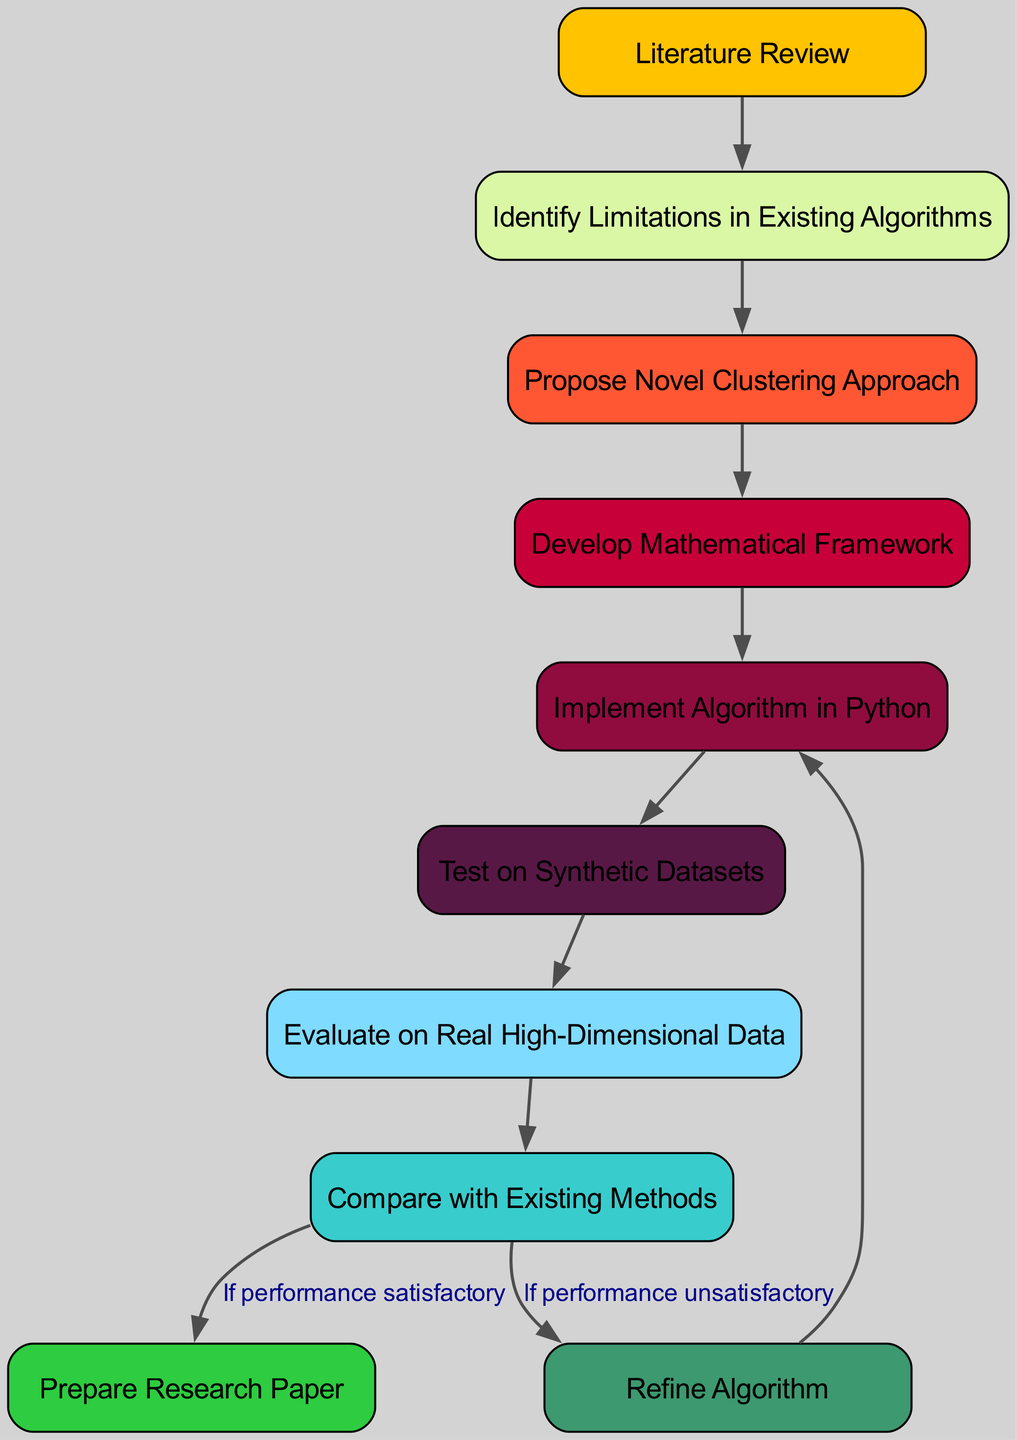What is the first step in the process? The first node in the diagram is "Literature Review," indicating that this is the initial step in the development of the clustering algorithm.
Answer: Literature Review How many nodes are present in the diagram? The diagram lists a total of ten nodes representing different steps in developing the clustering algorithm.
Answer: 10 What is the immediate next step after "Propose Novel Clustering Approach"? The flowchart indicates that after proposing a novel approach, the next step is to "Develop Mathematical Framework," which connects these two nodes.
Answer: Develop Mathematical Framework What decision follows the "Evaluate on Real High-Dimensional Data" step? After evaluating on real high-dimensional data, the flowchart leads to two paths: if performance is satisfactory, it goes to "Prepare Research Paper"; if not, it goes to "Compare with Existing Methods." This illustrates a decision point based on performance.
Answer: Compare with Existing Methods or Prepare Research Paper What is the process to refine the algorithm? To refine the algorithm, the diagram shows moving from "Compare with Existing Methods" and, if performance is unsatisfactory, returning to "Implement Algorithm in Python," indicating an iterative improvement process.
Answer: Implement Algorithm in Python What happens after "Test on Synthetic Datasets"? Following the testing on synthetic datasets, the next step is "Evaluate on Real High-Dimensional Data," indicating a progression to real-world application after initial synthetic testing.
Answer: Evaluate on Real High-Dimensional Data Which node is connected to the "Identify Limitations in Existing Algorithms"? The node directly connected to "Identify Limitations in Existing Algorithms" is "Propose Novel Clustering Approach," indicating that this step directly follows the identification of limitations.
Answer: Propose Novel Clustering Approach What is the overall direction of the flow in the diagram? The diagram flows from top to bottom, representing a sequential and logical progression through the steps required to develop the novel clustering algorithm, indicating a structured approach to problem-solving.
Answer: Top to bottom 